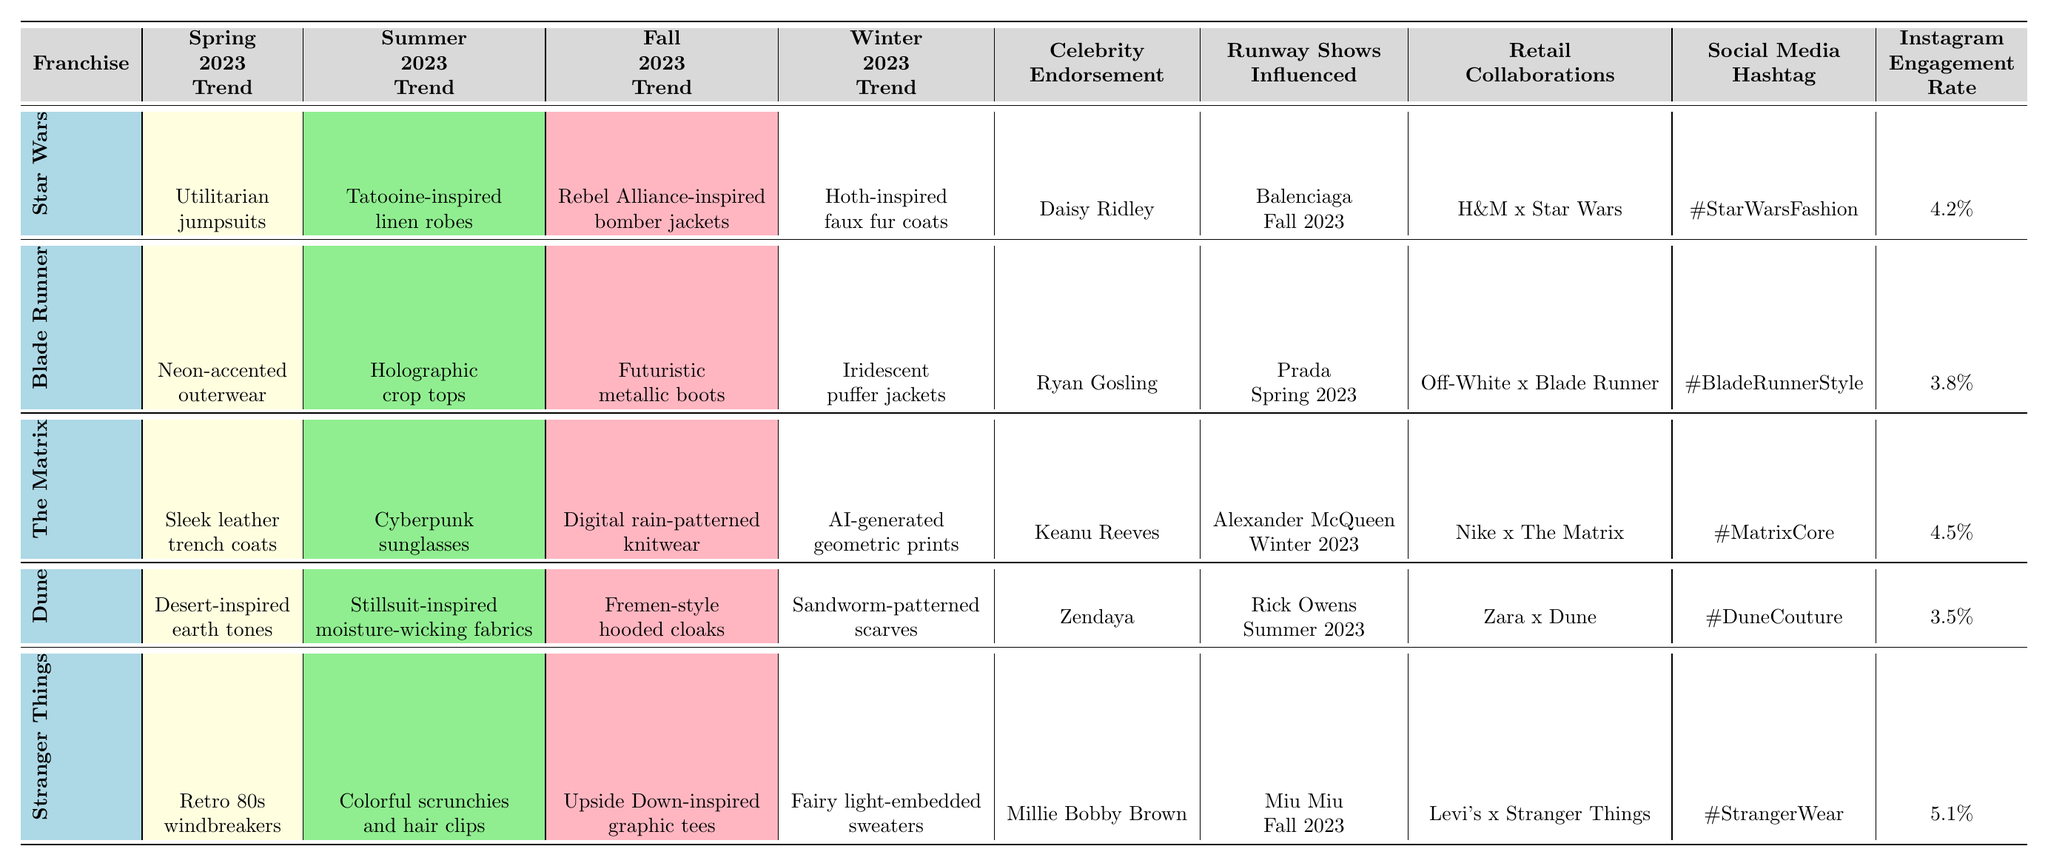What fashion trend is associated with Star Wars in Winter 2023? According to the table, the Winter 2023 trend for Star Wars is "Hoth-inspired faux fur coats."
Answer: Hoth-inspired faux fur coats Which franchise has the highest Instagram engagement rate? By comparing the engagement rates listed for all franchises, Stranger Things has the highest rate at 5.1%.
Answer: Stranger Things What is the common characteristic of the Summer 2023 trends for The Matrix and Blade Runner? Both trends involve futuristic aesthetics; The Matrix features "Cyberpunk sunglasses" while Blade Runner includes "Holographic crop tops," emphasizing a tech-forward style.
Answer: Futuristic aesthetics Which celebrity is endorsing the fashion trends associated with Dune? The table indicates that Zendaya is the celebrity endorsement for Dune's fashion trends.
Answer: Zendaya Is there a collaboration between a retailer and the Star Wars franchise? Yes, H&M has a collaboration with Star Wars as shown in the retail collaborations section of the table.
Answer: Yes For which franchise did the Fall 2023 trend include a bomber jacket? The Fall 2023 trend for Star Wars included a "Rebel Alliance-inspired bomber jacket."
Answer: Star Wars How many franchises have their fashion trends associated with earth tones during Spring 2023? Only Dune features "Desert-inspired earth tones" as its trend in Spring 2023, indicating just one franchise with this characteristic.
Answer: One franchise What trend is reflected in the Fall 2023 collection influenced by Rick Owens? The trend influenced by Rick Owens for Fall 2023 is "Fremen-style hooded cloaks" from the Dune franchise.
Answer: Fremen-style hooded cloaks Which retailer collaboration involves Stranger Things and what social media hashtag is related to it? The collaboration involving Stranger Things is with Levi's, and the related social media hashtag is "#StrangerWear."
Answer: Levi's; #StrangerWear Compare the Winter 2023 trends of The Matrix and Dune. Which trend has a more vibrant description? The Winter 2023 trend for The Matrix "AI-generated geometric prints" suggests a vibrant, artistic aspect, while Dune's is "Sandworm-patterned scarves," which is less vibrant. Thus, The Matrix has a more vibrant description.
Answer: The Matrix 